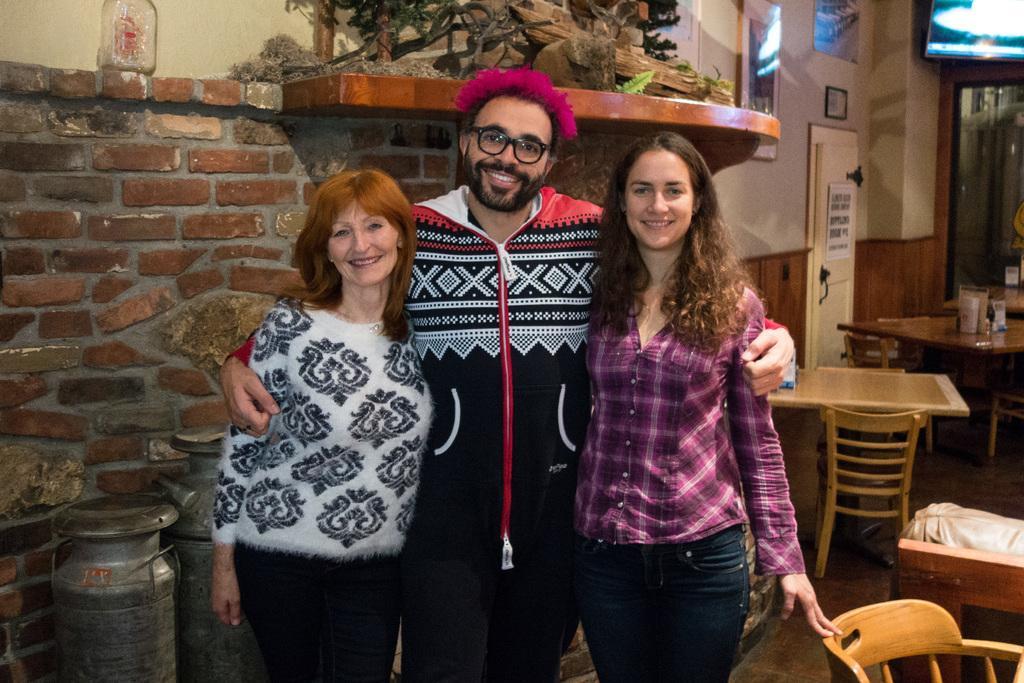Can you describe this image briefly? This picture shows two man and a man standing with a smile on their faces and we see few view tables and chairs 